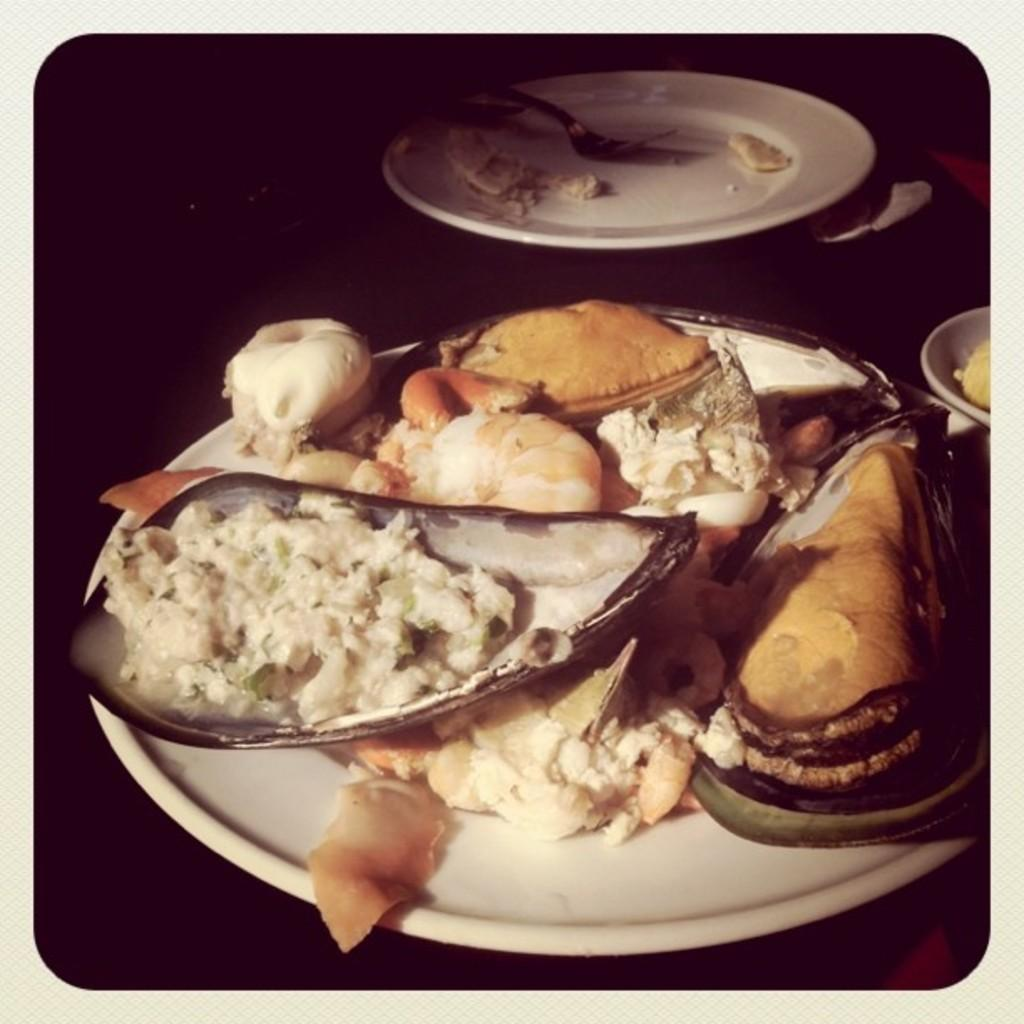What celestial bodies are depicted in the image? There are planets in the image. What type of food can be seen on a plate in the image? There is food on a plate in the image. What utensil is present with the food on the plate? There is a fork in the plate in the image. What is the color of the background in the image? The background of the image is dark. What type of chin can be seen on the school in the image? There is no school or chin present in the image; it features planets and food on a plate. 